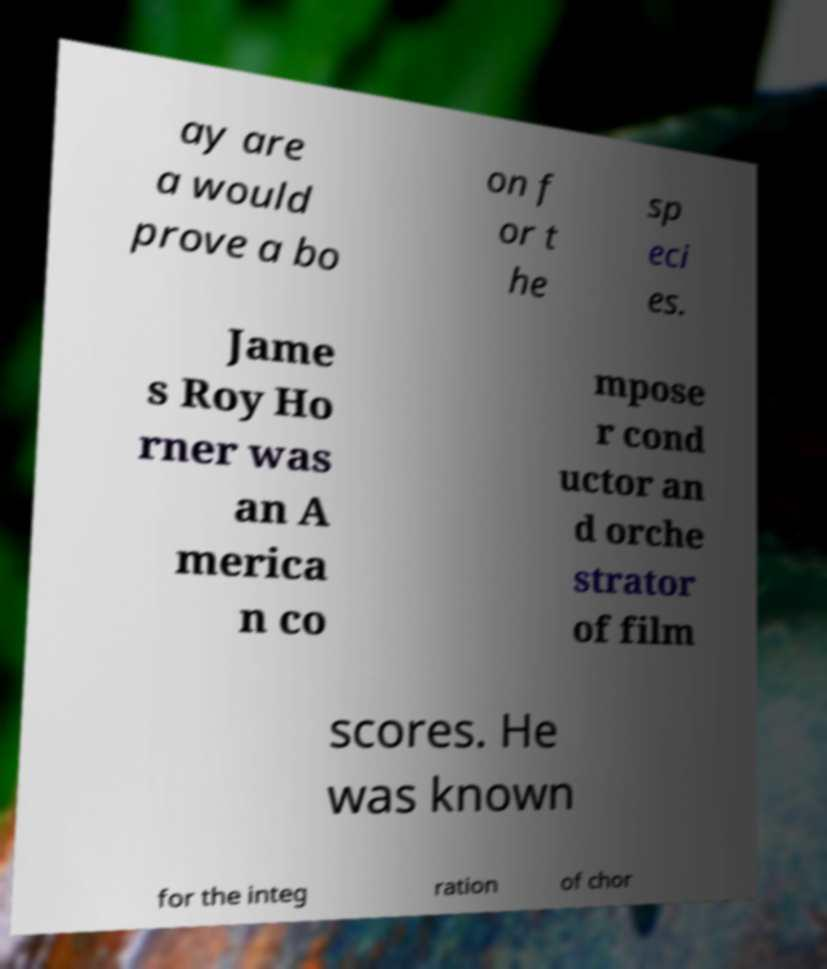Could you extract and type out the text from this image? ay are a would prove a bo on f or t he sp eci es. Jame s Roy Ho rner was an A merica n co mpose r cond uctor an d orche strator of film scores. He was known for the integ ration of chor 